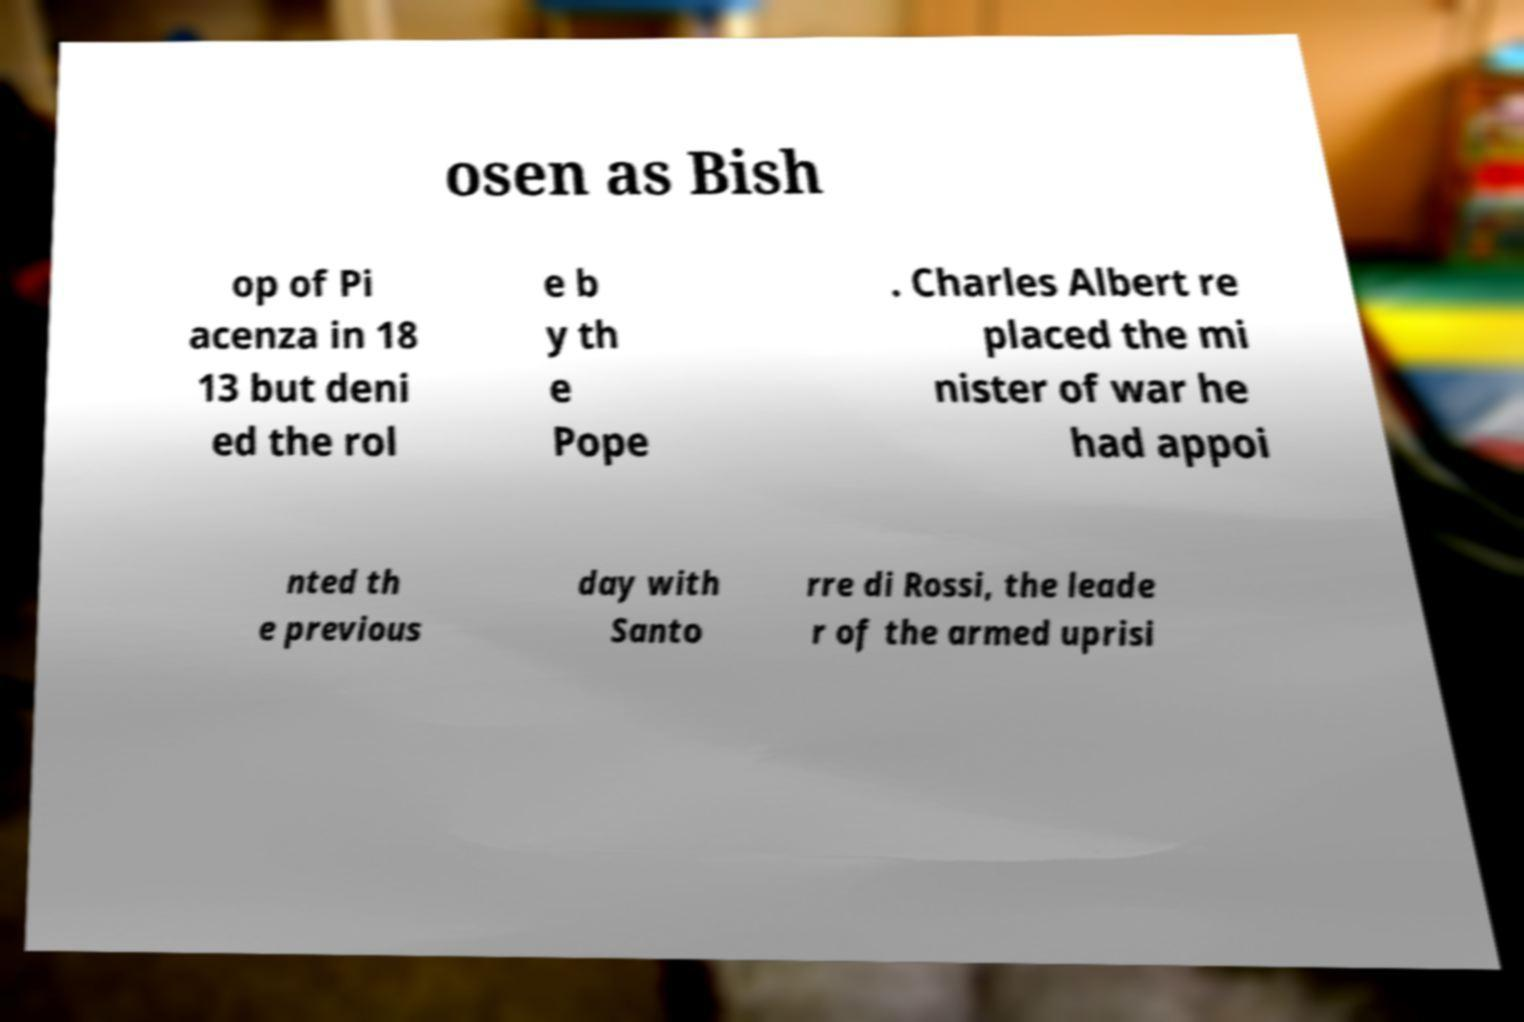For documentation purposes, I need the text within this image transcribed. Could you provide that? osen as Bish op of Pi acenza in 18 13 but deni ed the rol e b y th e Pope . Charles Albert re placed the mi nister of war he had appoi nted th e previous day with Santo rre di Rossi, the leade r of the armed uprisi 